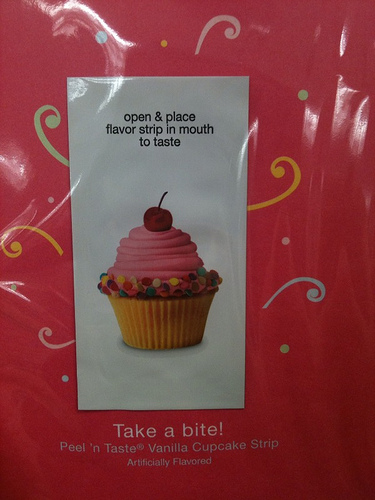<image>
Can you confirm if the talisman is in front of the merchant? No. The talisman is not in front of the merchant. The spatial positioning shows a different relationship between these objects. 